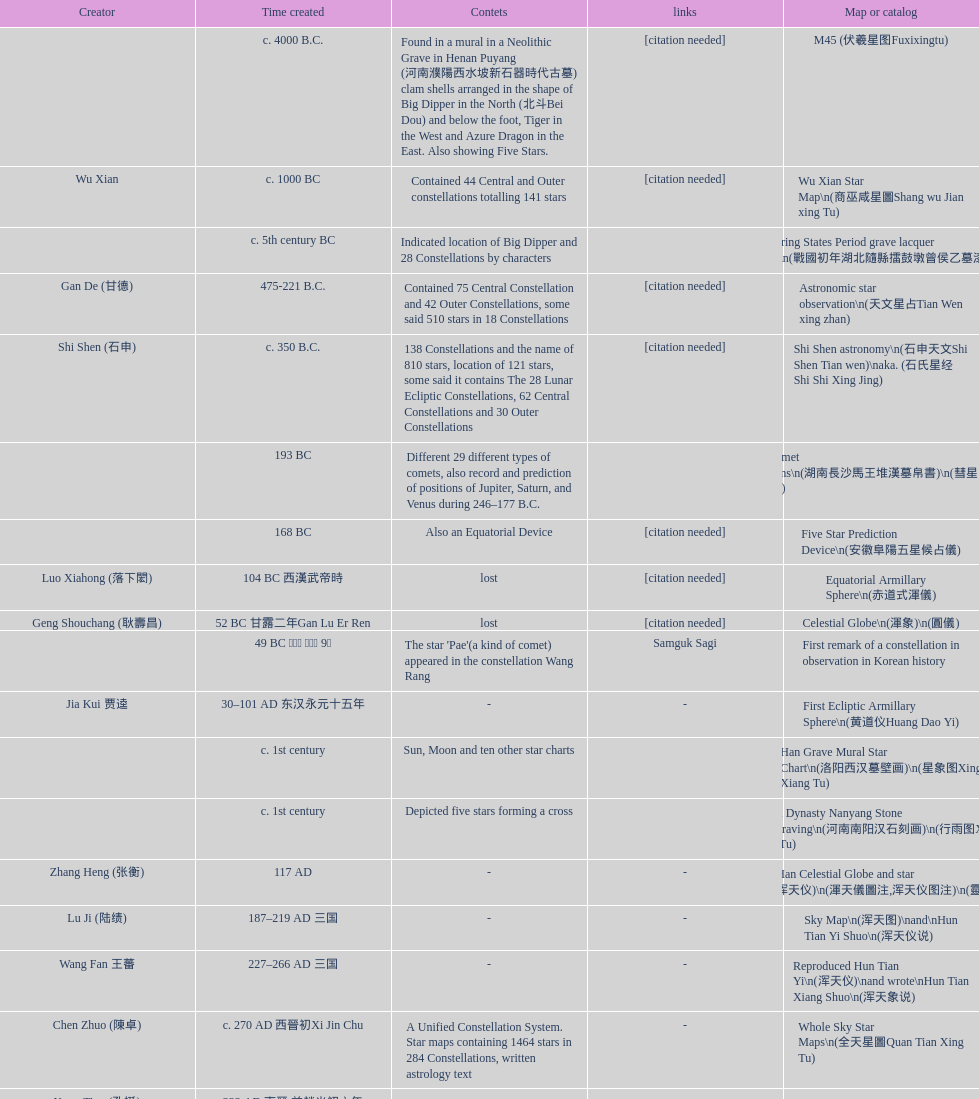Which was the first chinese star map known to have been created? M45 (伏羲星图Fuxixingtu). 